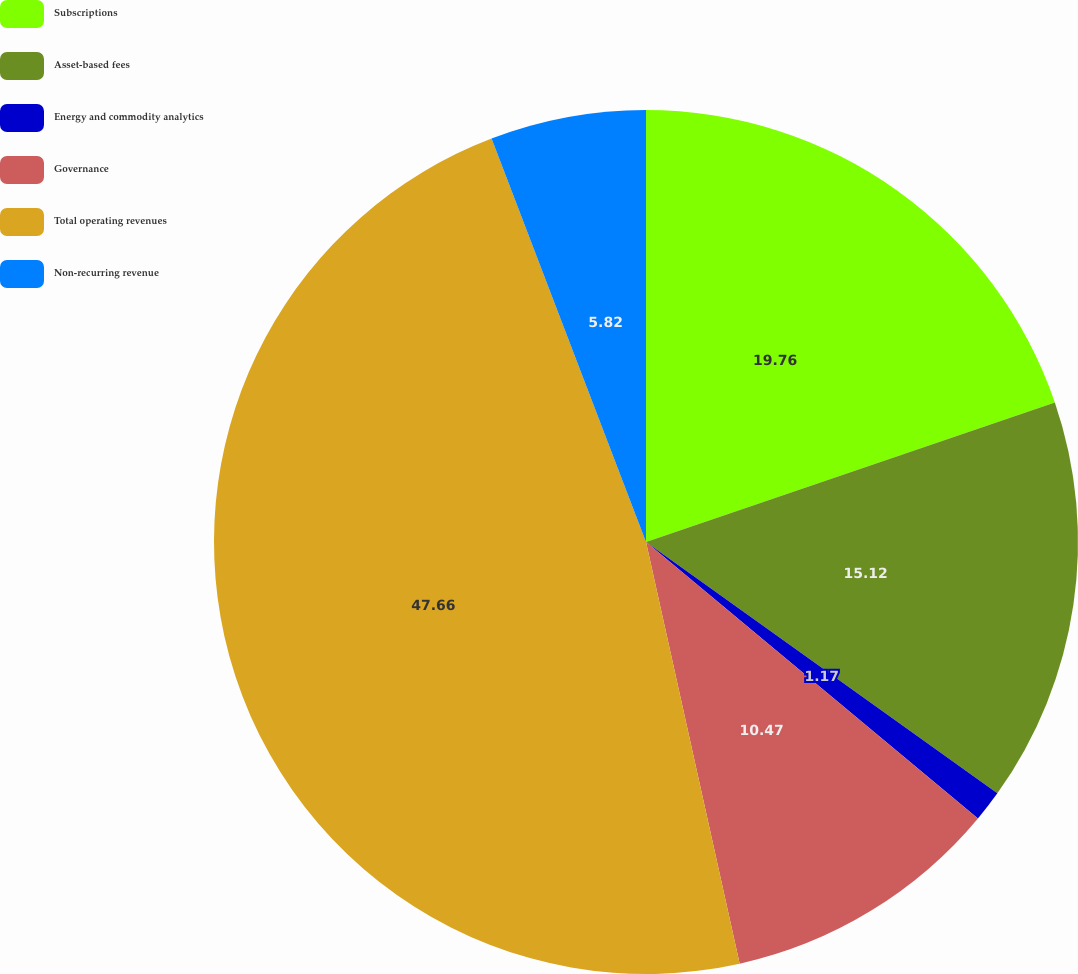Convert chart. <chart><loc_0><loc_0><loc_500><loc_500><pie_chart><fcel>Subscriptions<fcel>Asset-based fees<fcel>Energy and commodity analytics<fcel>Governance<fcel>Total operating revenues<fcel>Non-recurring revenue<nl><fcel>19.77%<fcel>15.12%<fcel>1.17%<fcel>10.47%<fcel>47.67%<fcel>5.82%<nl></chart> 